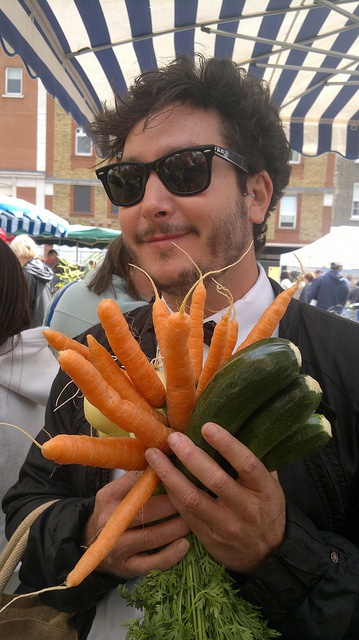Describe the objects in this image and their specific colors. I can see people in tan, black, brown, maroon, and gray tones, umbrella in tan, gray, ivory, and darkgray tones, people in tan, darkgray, black, gray, and lightgray tones, people in tan, darkgray, gray, and black tones, and carrot in tan, black, brown, and red tones in this image. 